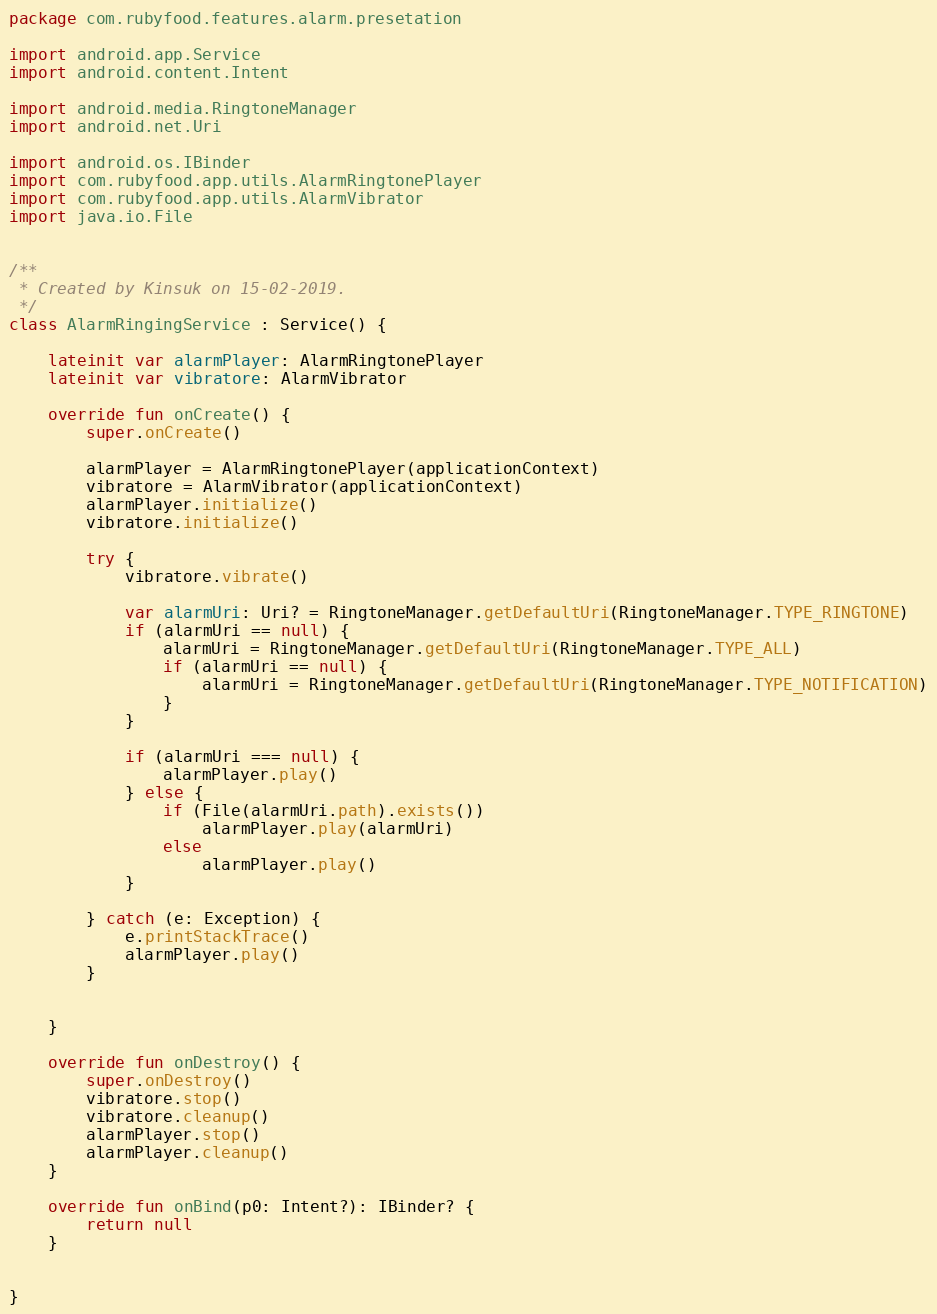Convert code to text. <code><loc_0><loc_0><loc_500><loc_500><_Kotlin_>package com.rubyfood.features.alarm.presetation

import android.app.Service
import android.content.Intent

import android.media.RingtoneManager
import android.net.Uri

import android.os.IBinder
import com.rubyfood.app.utils.AlarmRingtonePlayer
import com.rubyfood.app.utils.AlarmVibrator
import java.io.File


/**
 * Created by Kinsuk on 15-02-2019.
 */
class AlarmRingingService : Service() {

    lateinit var alarmPlayer: AlarmRingtonePlayer
    lateinit var vibratore: AlarmVibrator

    override fun onCreate() {
        super.onCreate()

        alarmPlayer = AlarmRingtonePlayer(applicationContext)
        vibratore = AlarmVibrator(applicationContext)
        alarmPlayer.initialize()
        vibratore.initialize()

        try {
            vibratore.vibrate()

            var alarmUri: Uri? = RingtoneManager.getDefaultUri(RingtoneManager.TYPE_RINGTONE)
            if (alarmUri == null) {
                alarmUri = RingtoneManager.getDefaultUri(RingtoneManager.TYPE_ALL)
                if (alarmUri == null) {
                    alarmUri = RingtoneManager.getDefaultUri(RingtoneManager.TYPE_NOTIFICATION)
                }
            }

            if (alarmUri === null) {
                alarmPlayer.play()
            } else {
                if (File(alarmUri.path).exists())
                    alarmPlayer.play(alarmUri)
                else
                    alarmPlayer.play()
            }

        } catch (e: Exception) {
            e.printStackTrace()
            alarmPlayer.play()
        }


    }

    override fun onDestroy() {
        super.onDestroy()
        vibratore.stop()
        vibratore.cleanup()
        alarmPlayer.stop()
        alarmPlayer.cleanup()
    }

    override fun onBind(p0: Intent?): IBinder? {
        return null
    }


}</code> 